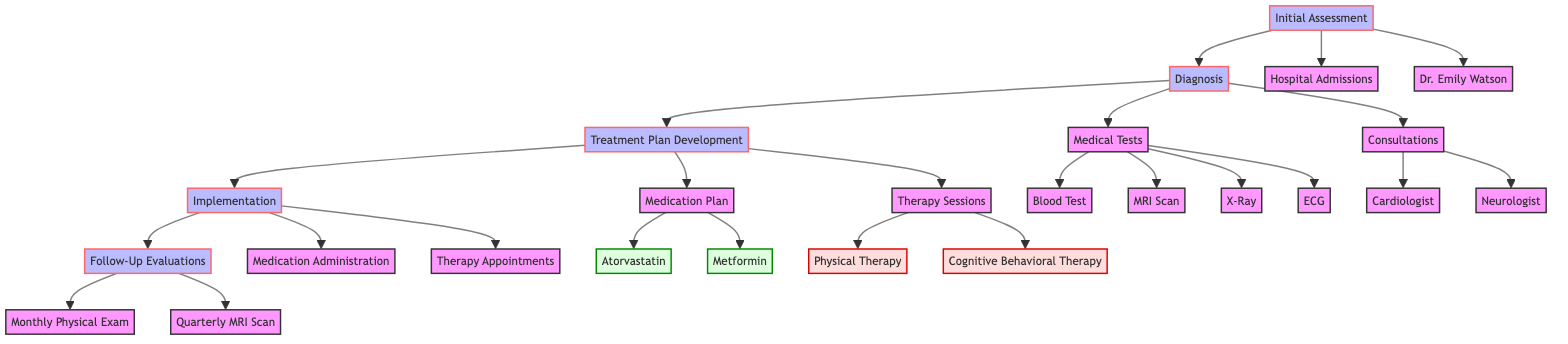What is the first step in the clinical pathway? The diagram shows that the first step in the clinical pathway is the "Initial Assessment." This is the starting node that leads to all subsequent steps in the process.
Answer: Initial Assessment How many medical tests are listed? In the diagnosis section of the diagram, there are four medical tests: Blood Test, MRI Scan, X-Ray, and ECG. By counting each listed test, we find there are four in total.
Answer: 4 Who is the primary physician for the patient? The diagram indicates that the primary physician is Dr. Emily Watson, mentioned directly in the "Initial Assessment" section of the flowchart.
Answer: Dr. Emily Watson What is the frequency of the Cognitive Behavioral Therapy sessions? Looking at the "Therapy Sessions" section, the diagram specifies that Cognitive Behavioral Therapy sessions occur weekly. This indicates the regular interval at which these sessions are scheduled.
Answer: Weekly How many evaluators are involved in the Follow-Up Evaluations? In the "Follow-Up Evaluations" section, there are two evaluators mentioned: Dr. Emily Watson for the Monthly Physical Exam and Dr. Linda Taylor for the Quarterly MRI Scan. Therefore, two evaluators are involved.
Answer: 2 What type of therapy is provided thrice weekly? The "Therapy Sessions" part of the diagram lists Physical Therapy with a frequency of thrice weekly. This indicates the schedule for this specific type of therapy, shown clearly in the therapy section.
Answer: Physical Therapy Which two medications are included in the Medication Plan? The "Medication Plan" part identifies two medications: Atorvastatin and Metformin. Each medication's name is listed here, making it straightforward to see what is included in the plan.
Answer: Atorvastatin, Metformin What is the evaluator for the Quarterly MRI Scan? The diagram clearly indicates that the evaluator for the Quarterly MRI Scan is Dr. Linda Taylor. This specifies who will be conducting this particular follow-up evaluation.
Answer: Dr. Linda Taylor Where will the physical therapy sessions take place? In the implementation section under "Therapy Appointments," the diagram specifies that physical therapy sessions will be held at the Physical Therapy Center on Monday, Wednesday, and Friday. This location is clearly stated in the diagram.
Answer: Physical Therapy Center 